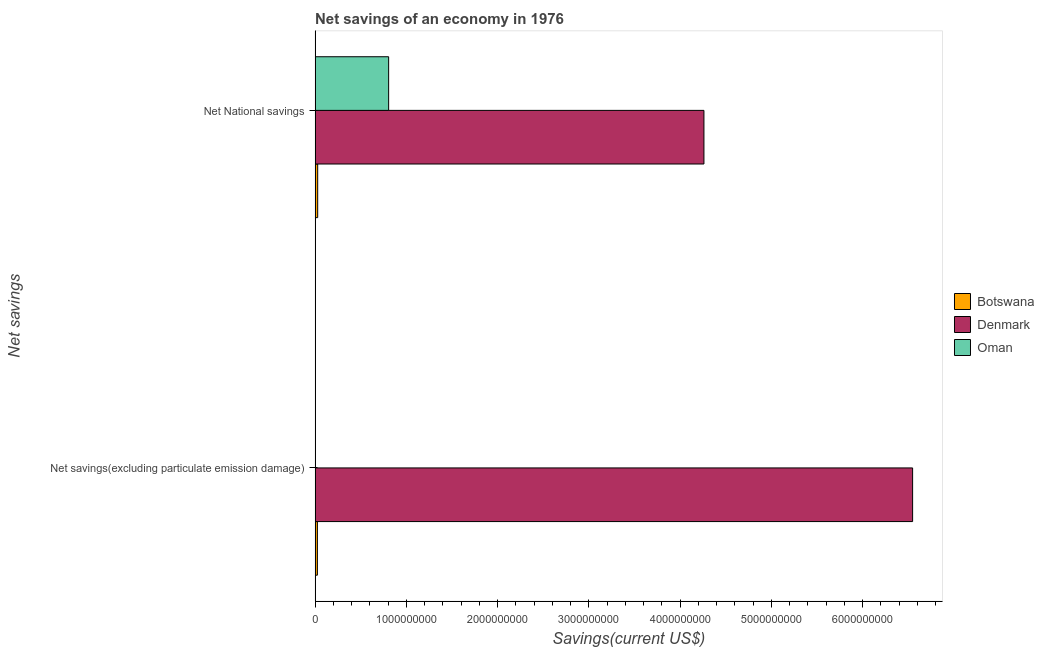How many bars are there on the 1st tick from the top?
Your answer should be very brief. 3. How many bars are there on the 2nd tick from the bottom?
Your answer should be very brief. 3. What is the label of the 2nd group of bars from the top?
Keep it short and to the point. Net savings(excluding particulate emission damage). What is the net national savings in Denmark?
Your response must be concise. 4.26e+09. Across all countries, what is the maximum net savings(excluding particulate emission damage)?
Give a very brief answer. 6.55e+09. Across all countries, what is the minimum net national savings?
Give a very brief answer. 2.83e+07. What is the total net savings(excluding particulate emission damage) in the graph?
Give a very brief answer. 6.57e+09. What is the difference between the net national savings in Oman and that in Denmark?
Provide a succinct answer. -3.46e+09. What is the difference between the net national savings in Denmark and the net savings(excluding particulate emission damage) in Botswana?
Offer a terse response. 4.24e+09. What is the average net national savings per country?
Offer a very short reply. 1.70e+09. What is the difference between the net national savings and net savings(excluding particulate emission damage) in Botswana?
Give a very brief answer. 3.21e+06. In how many countries, is the net savings(excluding particulate emission damage) greater than 2800000000 US$?
Offer a very short reply. 1. What is the ratio of the net savings(excluding particulate emission damage) in Botswana to that in Denmark?
Your answer should be compact. 0. Is the net savings(excluding particulate emission damage) in Botswana less than that in Denmark?
Ensure brevity in your answer.  Yes. How many bars are there?
Provide a short and direct response. 5. Are all the bars in the graph horizontal?
Make the answer very short. Yes. What is the difference between two consecutive major ticks on the X-axis?
Keep it short and to the point. 1.00e+09. Does the graph contain any zero values?
Ensure brevity in your answer.  Yes. Does the graph contain grids?
Ensure brevity in your answer.  No. How many legend labels are there?
Give a very brief answer. 3. How are the legend labels stacked?
Provide a short and direct response. Vertical. What is the title of the graph?
Give a very brief answer. Net savings of an economy in 1976. Does "Korea (Republic)" appear as one of the legend labels in the graph?
Your answer should be very brief. No. What is the label or title of the X-axis?
Offer a terse response. Savings(current US$). What is the label or title of the Y-axis?
Offer a terse response. Net savings. What is the Savings(current US$) in Botswana in Net savings(excluding particulate emission damage)?
Keep it short and to the point. 2.51e+07. What is the Savings(current US$) in Denmark in Net savings(excluding particulate emission damage)?
Offer a terse response. 6.55e+09. What is the Savings(current US$) of Oman in Net savings(excluding particulate emission damage)?
Offer a very short reply. 0. What is the Savings(current US$) of Botswana in Net National savings?
Offer a very short reply. 2.83e+07. What is the Savings(current US$) of Denmark in Net National savings?
Ensure brevity in your answer.  4.26e+09. What is the Savings(current US$) of Oman in Net National savings?
Offer a terse response. 8.06e+08. Across all Net savings, what is the maximum Savings(current US$) of Botswana?
Offer a very short reply. 2.83e+07. Across all Net savings, what is the maximum Savings(current US$) of Denmark?
Provide a succinct answer. 6.55e+09. Across all Net savings, what is the maximum Savings(current US$) in Oman?
Provide a succinct answer. 8.06e+08. Across all Net savings, what is the minimum Savings(current US$) in Botswana?
Provide a succinct answer. 2.51e+07. Across all Net savings, what is the minimum Savings(current US$) in Denmark?
Offer a very short reply. 4.26e+09. Across all Net savings, what is the minimum Savings(current US$) of Oman?
Provide a succinct answer. 0. What is the total Savings(current US$) in Botswana in the graph?
Give a very brief answer. 5.34e+07. What is the total Savings(current US$) of Denmark in the graph?
Provide a succinct answer. 1.08e+1. What is the total Savings(current US$) of Oman in the graph?
Make the answer very short. 8.06e+08. What is the difference between the Savings(current US$) in Botswana in Net savings(excluding particulate emission damage) and that in Net National savings?
Your response must be concise. -3.21e+06. What is the difference between the Savings(current US$) in Denmark in Net savings(excluding particulate emission damage) and that in Net National savings?
Ensure brevity in your answer.  2.29e+09. What is the difference between the Savings(current US$) in Botswana in Net savings(excluding particulate emission damage) and the Savings(current US$) in Denmark in Net National savings?
Your response must be concise. -4.24e+09. What is the difference between the Savings(current US$) of Botswana in Net savings(excluding particulate emission damage) and the Savings(current US$) of Oman in Net National savings?
Offer a terse response. -7.81e+08. What is the difference between the Savings(current US$) of Denmark in Net savings(excluding particulate emission damage) and the Savings(current US$) of Oman in Net National savings?
Make the answer very short. 5.74e+09. What is the average Savings(current US$) of Botswana per Net savings?
Offer a very short reply. 2.67e+07. What is the average Savings(current US$) in Denmark per Net savings?
Offer a terse response. 5.40e+09. What is the average Savings(current US$) in Oman per Net savings?
Ensure brevity in your answer.  4.03e+08. What is the difference between the Savings(current US$) in Botswana and Savings(current US$) in Denmark in Net savings(excluding particulate emission damage)?
Your answer should be compact. -6.52e+09. What is the difference between the Savings(current US$) in Botswana and Savings(current US$) in Denmark in Net National savings?
Make the answer very short. -4.23e+09. What is the difference between the Savings(current US$) in Botswana and Savings(current US$) in Oman in Net National savings?
Keep it short and to the point. -7.78e+08. What is the difference between the Savings(current US$) of Denmark and Savings(current US$) of Oman in Net National savings?
Your answer should be compact. 3.46e+09. What is the ratio of the Savings(current US$) in Botswana in Net savings(excluding particulate emission damage) to that in Net National savings?
Provide a succinct answer. 0.89. What is the ratio of the Savings(current US$) in Denmark in Net savings(excluding particulate emission damage) to that in Net National savings?
Offer a terse response. 1.54. What is the difference between the highest and the second highest Savings(current US$) in Botswana?
Offer a terse response. 3.21e+06. What is the difference between the highest and the second highest Savings(current US$) of Denmark?
Your answer should be very brief. 2.29e+09. What is the difference between the highest and the lowest Savings(current US$) of Botswana?
Provide a succinct answer. 3.21e+06. What is the difference between the highest and the lowest Savings(current US$) of Denmark?
Keep it short and to the point. 2.29e+09. What is the difference between the highest and the lowest Savings(current US$) of Oman?
Your response must be concise. 8.06e+08. 